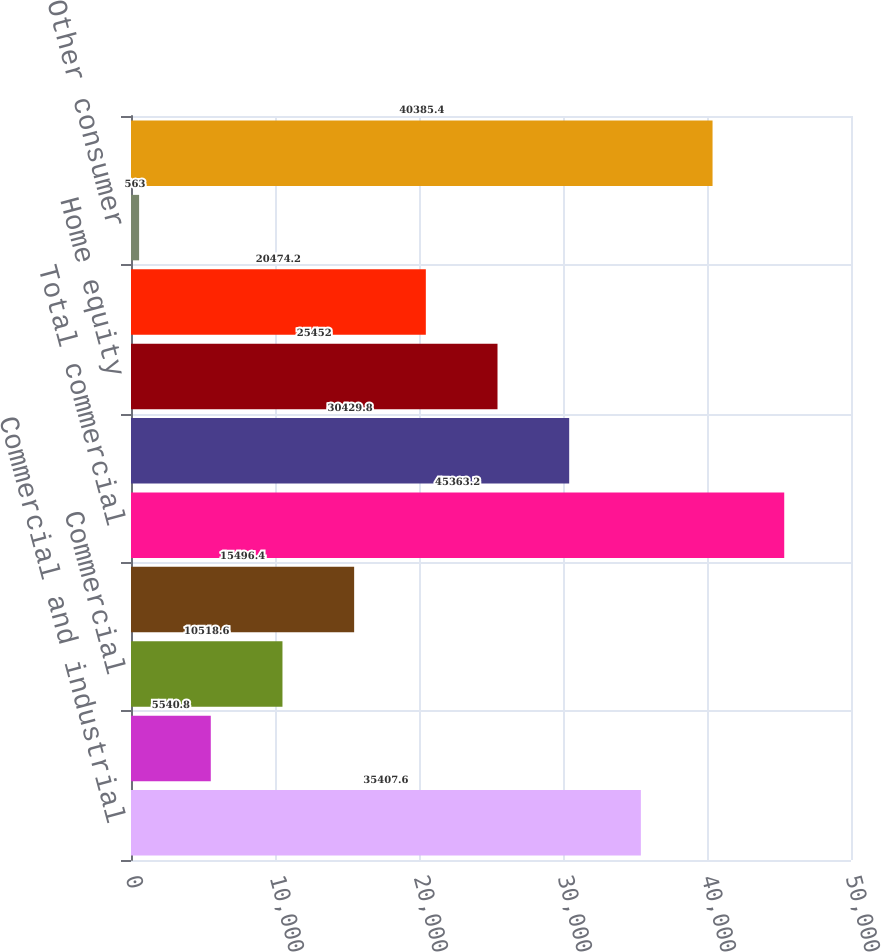Convert chart to OTSL. <chart><loc_0><loc_0><loc_500><loc_500><bar_chart><fcel>Commercial and industrial<fcel>Construction<fcel>Commercial<fcel>Total commercial real estate<fcel>Total commercial<fcel>Automobile<fcel>Home equity<fcel>Residential mortgage<fcel>Other consumer<fcel>Total consumer<nl><fcel>35407.6<fcel>5540.8<fcel>10518.6<fcel>15496.4<fcel>45363.2<fcel>30429.8<fcel>25452<fcel>20474.2<fcel>563<fcel>40385.4<nl></chart> 